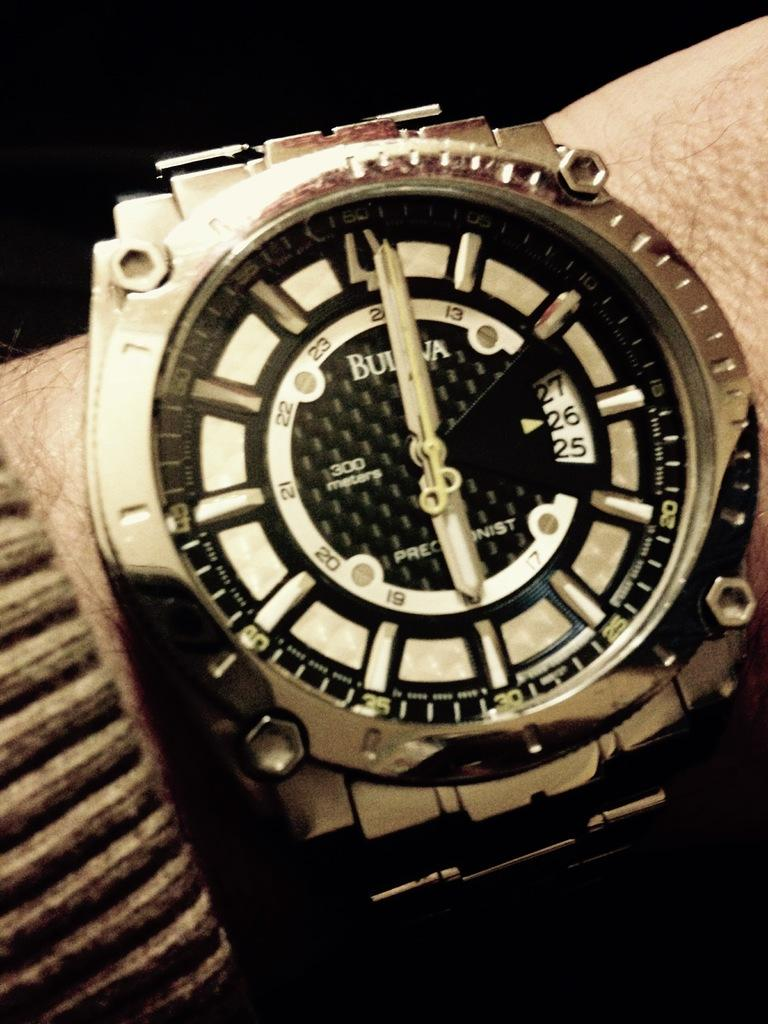<image>
Give a short and clear explanation of the subsequent image. A watch that says Bulova on it in metal. 